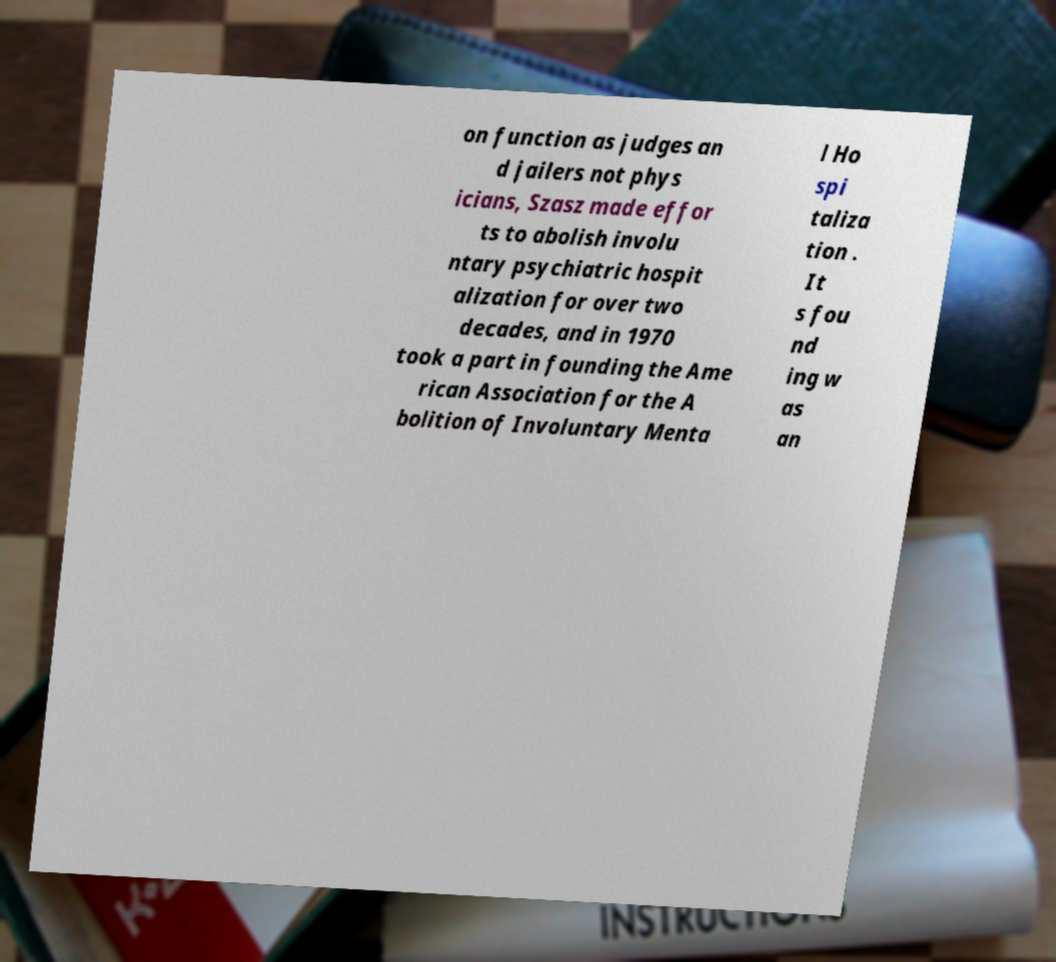Could you assist in decoding the text presented in this image and type it out clearly? on function as judges an d jailers not phys icians, Szasz made effor ts to abolish involu ntary psychiatric hospit alization for over two decades, and in 1970 took a part in founding the Ame rican Association for the A bolition of Involuntary Menta l Ho spi taliza tion . It s fou nd ing w as an 